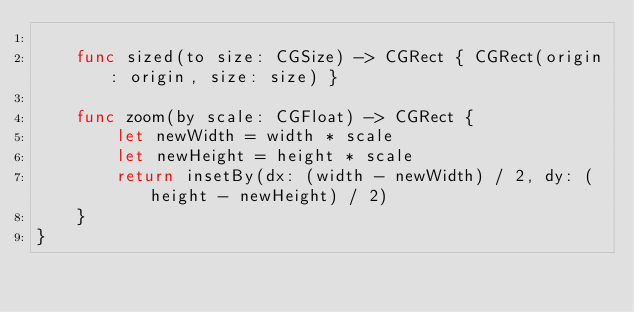Convert code to text. <code><loc_0><loc_0><loc_500><loc_500><_Swift_>    
    func sized(to size: CGSize) -> CGRect { CGRect(origin: origin, size: size) }
    
    func zoom(by scale: CGFloat) -> CGRect {
        let newWidth = width * scale
        let newHeight = height * scale
        return insetBy(dx: (width - newWidth) / 2, dy: (height - newHeight) / 2)
    }
}
</code> 